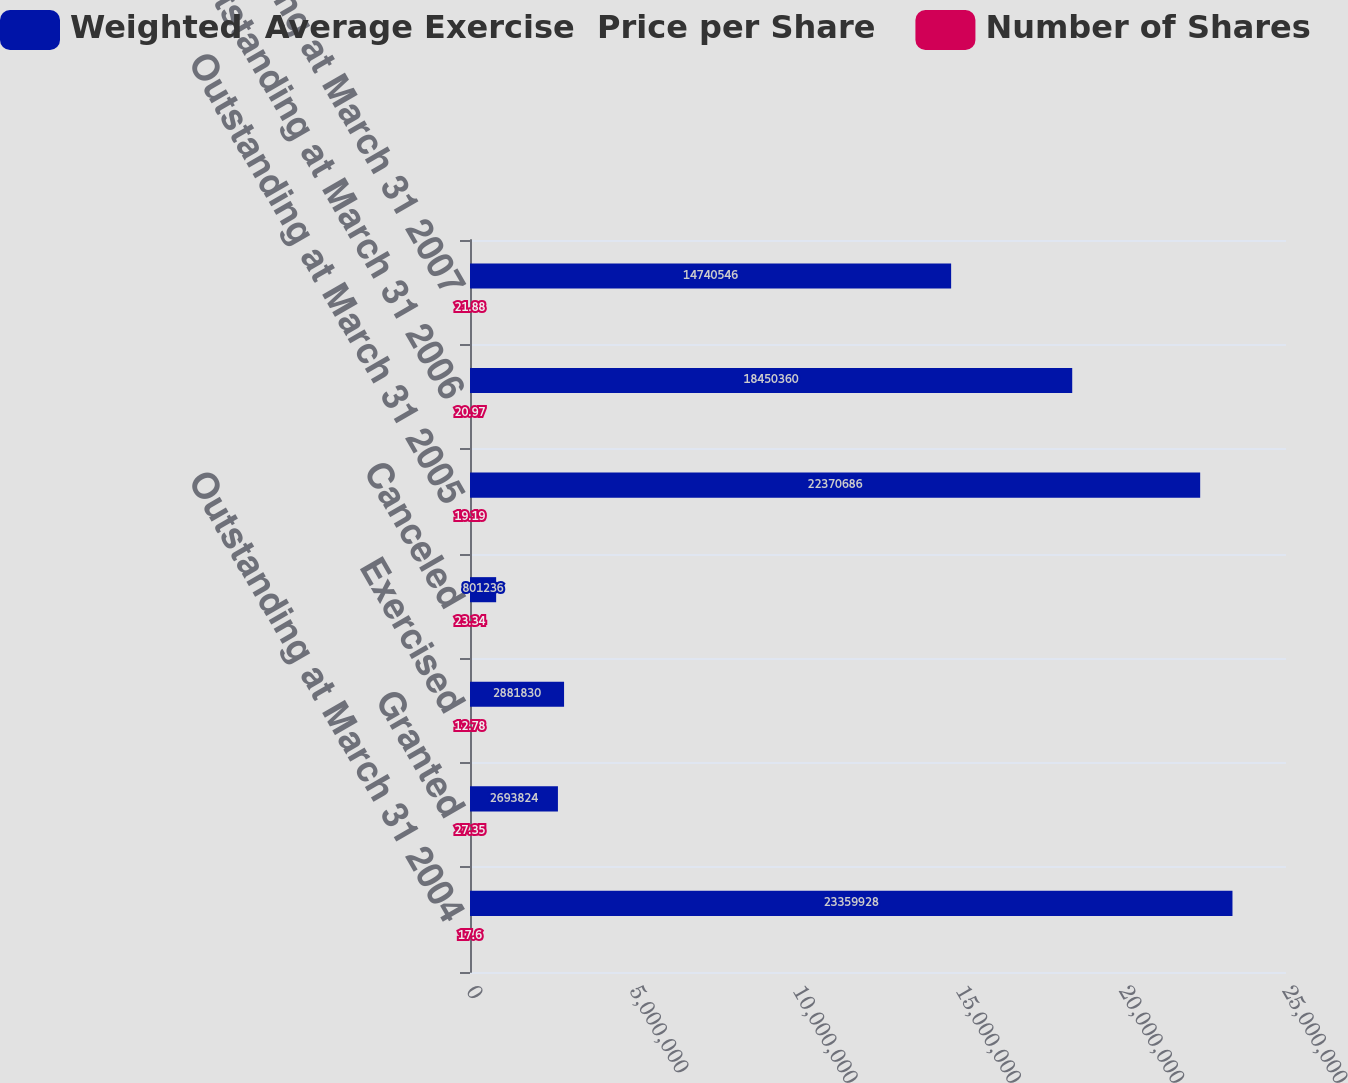Convert chart to OTSL. <chart><loc_0><loc_0><loc_500><loc_500><stacked_bar_chart><ecel><fcel>Outstanding at March 31 2004<fcel>Granted<fcel>Exercised<fcel>Canceled<fcel>Outstanding at March 31 2005<fcel>Outstanding at March 31 2006<fcel>Outstanding at March 31 2007<nl><fcel>Weighted  Average Exercise  Price per Share<fcel>2.33599e+07<fcel>2.69382e+06<fcel>2.88183e+06<fcel>801236<fcel>2.23707e+07<fcel>1.84504e+07<fcel>1.47405e+07<nl><fcel>Number of Shares<fcel>17.6<fcel>27.35<fcel>12.78<fcel>23.34<fcel>19.19<fcel>20.97<fcel>21.88<nl></chart> 